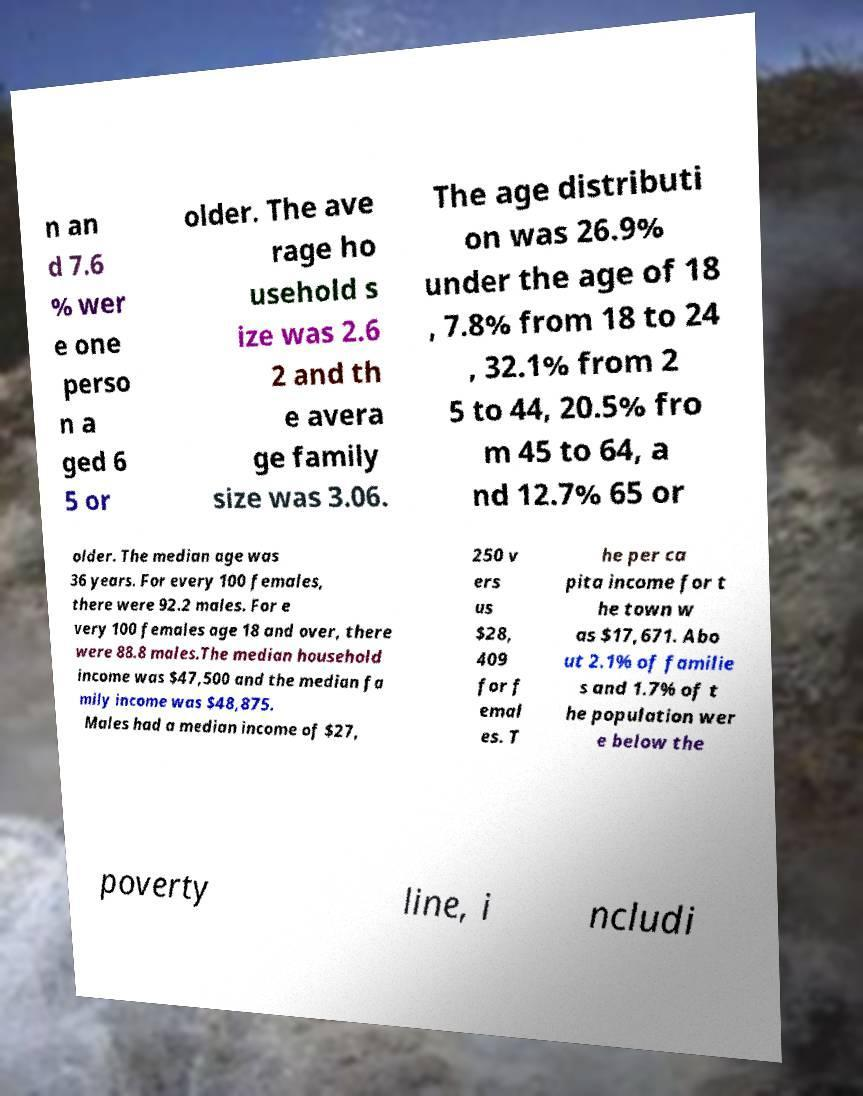For documentation purposes, I need the text within this image transcribed. Could you provide that? n an d 7.6 % wer e one perso n a ged 6 5 or older. The ave rage ho usehold s ize was 2.6 2 and th e avera ge family size was 3.06. The age distributi on was 26.9% under the age of 18 , 7.8% from 18 to 24 , 32.1% from 2 5 to 44, 20.5% fro m 45 to 64, a nd 12.7% 65 or older. The median age was 36 years. For every 100 females, there were 92.2 males. For e very 100 females age 18 and over, there were 88.8 males.The median household income was $47,500 and the median fa mily income was $48,875. Males had a median income of $27, 250 v ers us $28, 409 for f emal es. T he per ca pita income for t he town w as $17,671. Abo ut 2.1% of familie s and 1.7% of t he population wer e below the poverty line, i ncludi 